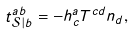Convert formula to latex. <formula><loc_0><loc_0><loc_500><loc_500>t _ { \mathcal { S } | b } ^ { a b } = - h _ { c } ^ { a } T ^ { c d } n _ { d } ,</formula> 